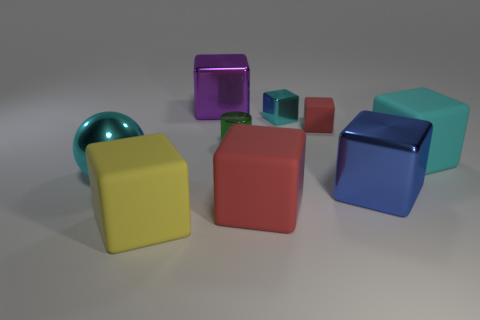Can you tell me about the objects' colors and how they are arranged? Certainly! The objects consist of various geometric shapes including cubes and a sphere, with colors such as cyan, yellow, red, green, purple, and blue. They're arranged randomly on a flat surface. Which color seems to be the most dominant? The color cyan appears to be quite dominant, particularly because of the large cyan cube that draws immediate attention. 